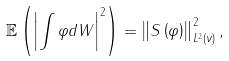Convert formula to latex. <formula><loc_0><loc_0><loc_500><loc_500>\mathbb { E } \left ( \left | \int \varphi d W \right | ^ { 2 } \right ) = \left \| S \left ( \varphi \right ) \right \| _ { L ^ { 2 } \left ( \nu \right ) } ^ { 2 } ,</formula> 